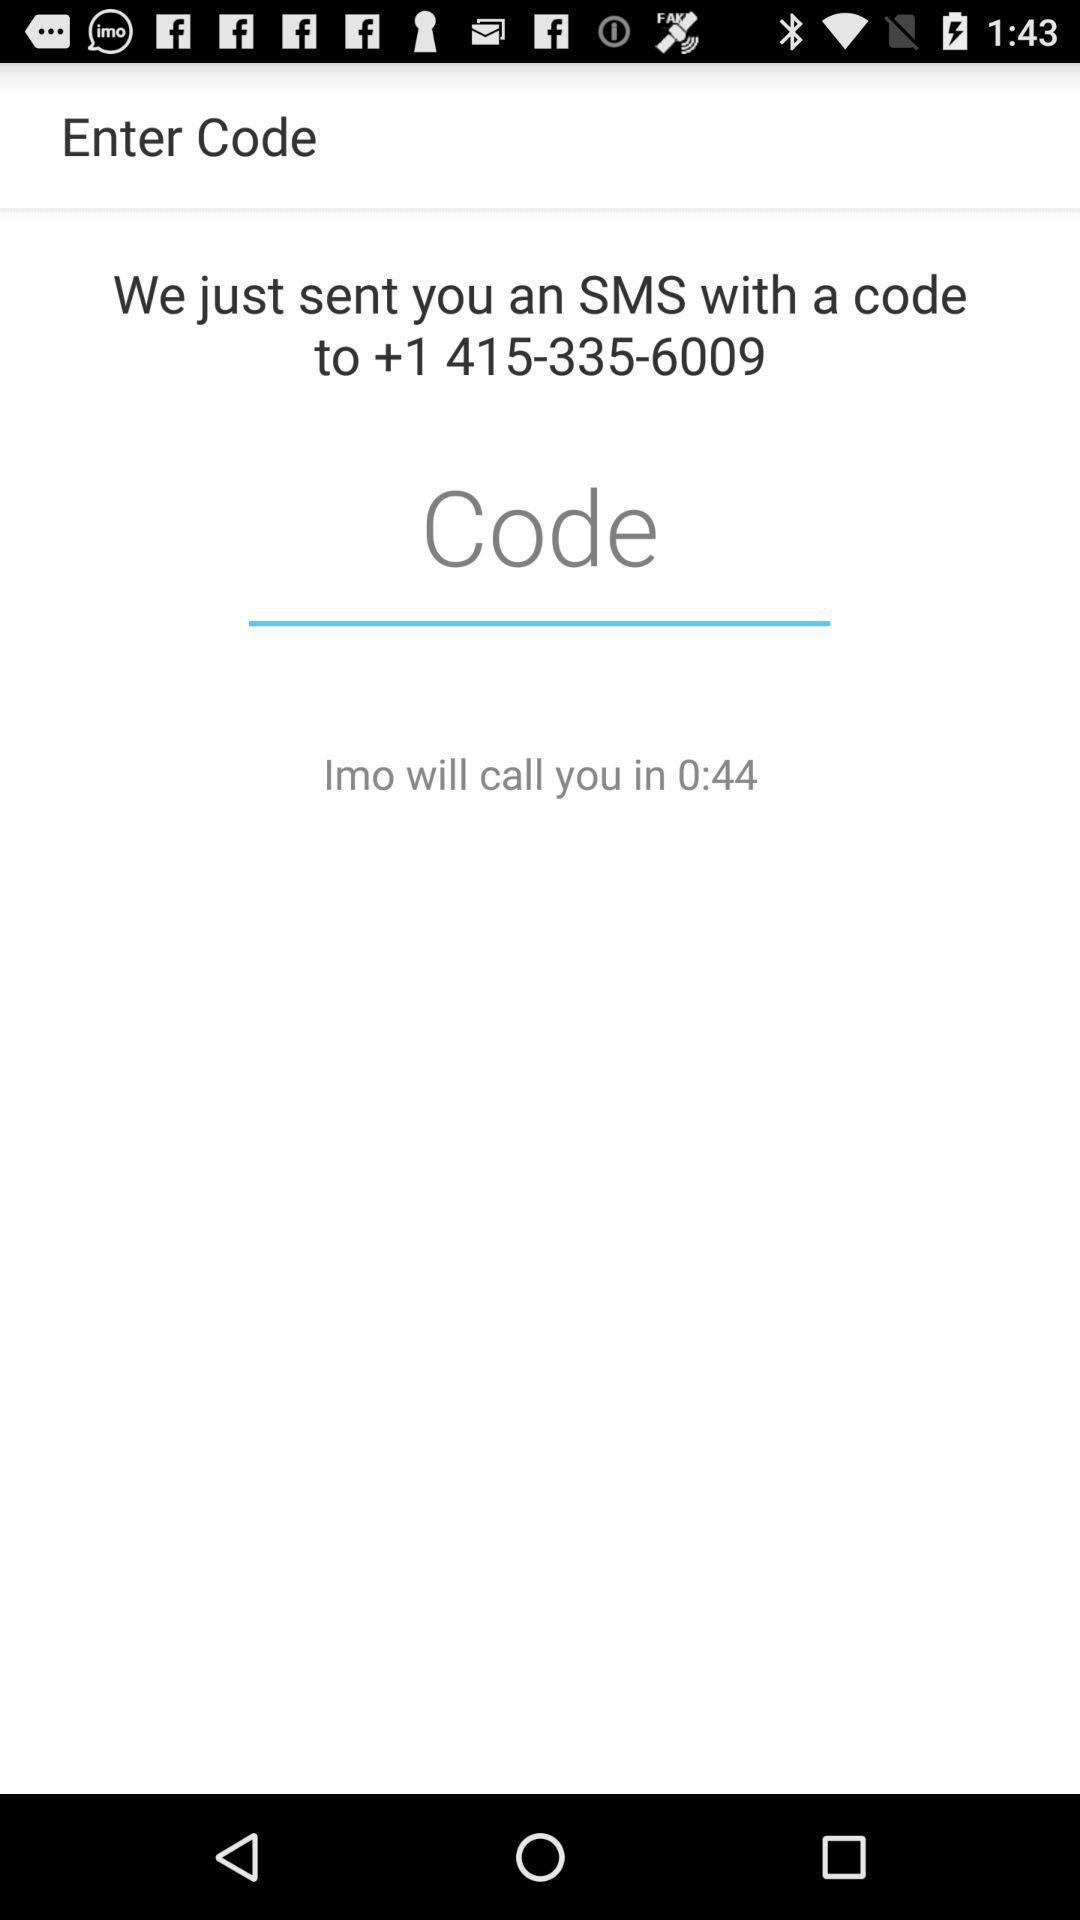Give me a narrative description of this picture. Screen showing to enter code option. 